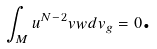Convert formula to latex. <formula><loc_0><loc_0><loc_500><loc_500>\int _ { M } u ^ { N - 2 } v w d v _ { g } = 0 \text {.}</formula> 